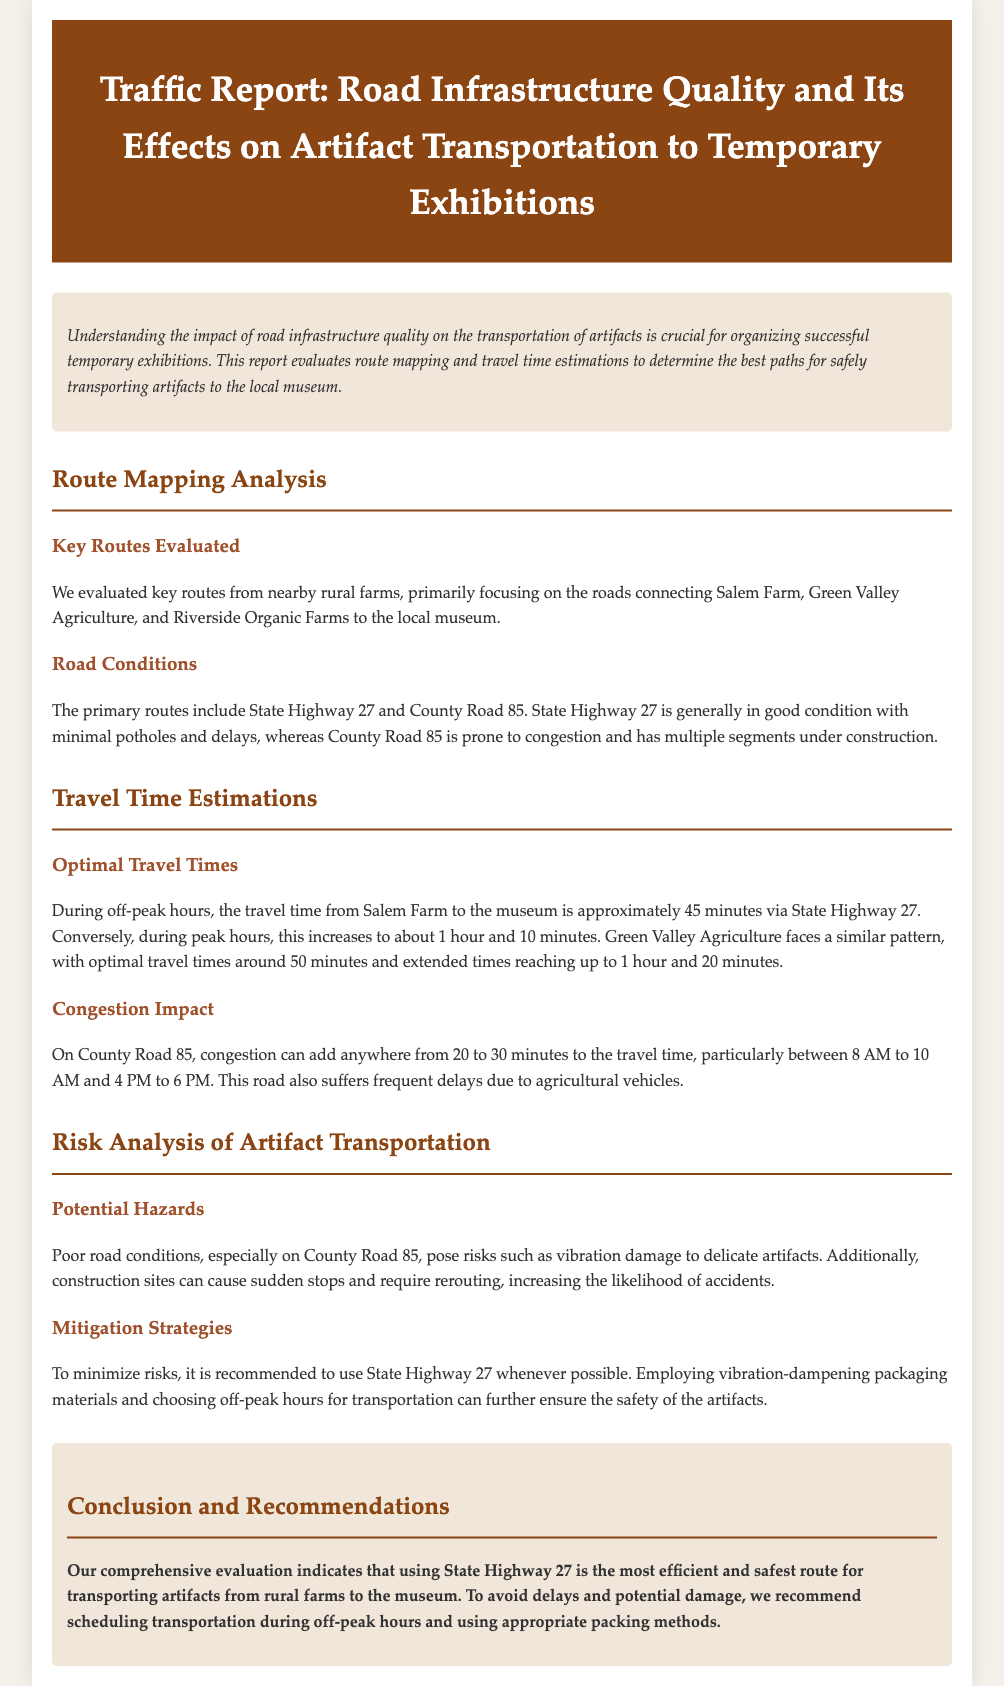What are the primary routes evaluated? The primary routes evaluated are State Highway 27 and County Road 85.
Answer: State Highway 27 and County Road 85 What is the travel time from Salem Farm to the museum during off-peak hours? During off-peak hours, the travel time from Salem Farm to the museum is approximately 45 minutes.
Answer: 45 minutes What road is generally in good condition? The document states that State Highway 27 is generally in good condition.
Answer: State Highway 27 What time period does congestion on County Road 85 primarily occur? Congestion on County Road 85 mainly occurs between 8 AM to 10 AM and 4 PM to 6 PM.
Answer: 8 AM to 10 AM and 4 PM to 6 PM What packing method is recommended for artifact transportation? It is recommended to employ vibration-dampening packaging materials for artifact transportation.
Answer: Vibration-dampening packaging materials Which route is suggested to minimize risks for artifact transportation? To minimize risks, it is recommended to use State Highway 27 whenever possible.
Answer: State Highway 27 What type of damage can poor road conditions cause to artifacts? Poor road conditions can cause vibration damage to delicate artifacts.
Answer: Vibration damage What is the conclusion regarding the best transportation scheduling? The conclusion recommends scheduling transportation during off-peak hours.
Answer: Off-peak hours 